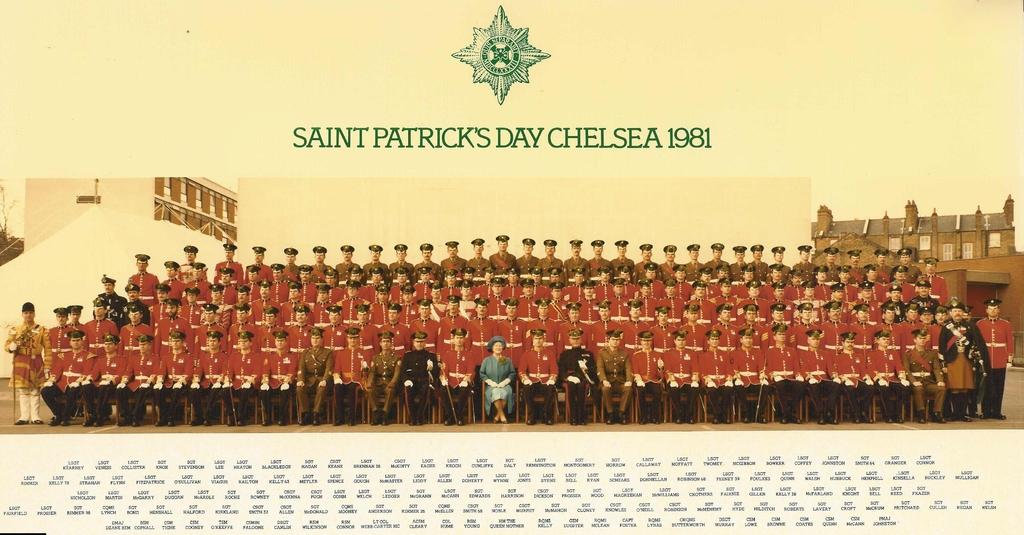<image>
Give a short and clear explanation of the subsequent image. A group photograph made on Saint Patrick's day in 1981 